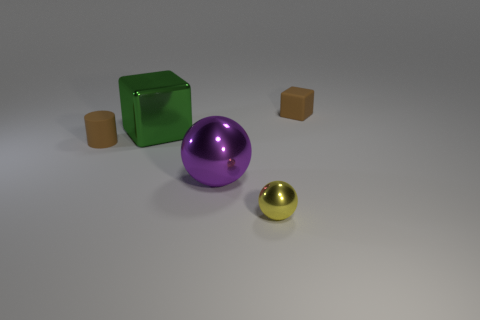Add 2 small green metal cylinders. How many objects exist? 7 Subtract all green blocks. How many blocks are left? 1 Subtract all cylinders. How many objects are left? 4 Subtract all green shiny objects. Subtract all brown cubes. How many objects are left? 3 Add 2 large metal things. How many large metal things are left? 4 Add 3 large gray rubber spheres. How many large gray rubber spheres exist? 3 Subtract 1 green cubes. How many objects are left? 4 Subtract all cyan cylinders. Subtract all gray blocks. How many cylinders are left? 1 